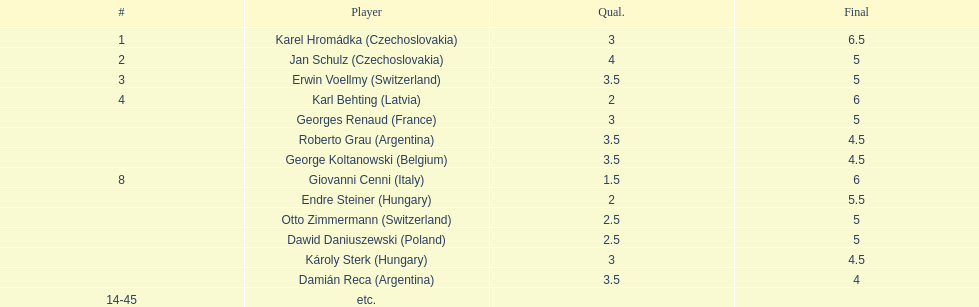Was the total score of the two hungarian competitors more or less than that of the two argentine competitors? Less. 